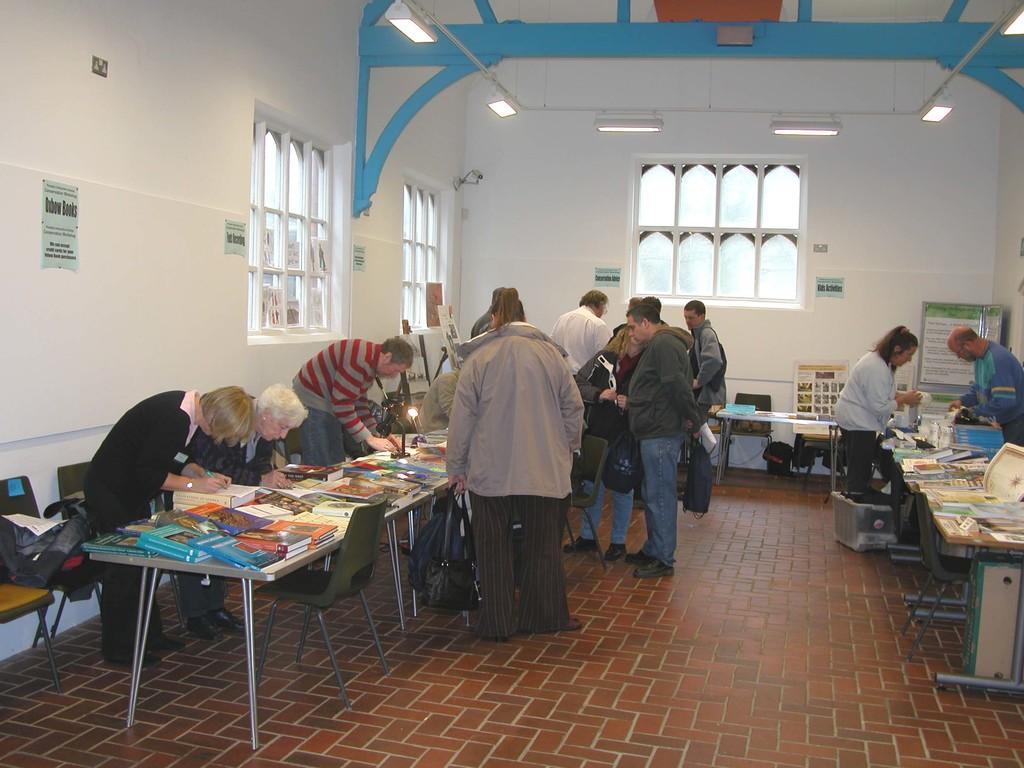How would you summarize this image in a sentence or two? There are many people standing here. There are many people, many tables arranged in a line. Some of them were writing something on the table. In the background we can observe windows and a wall here. 